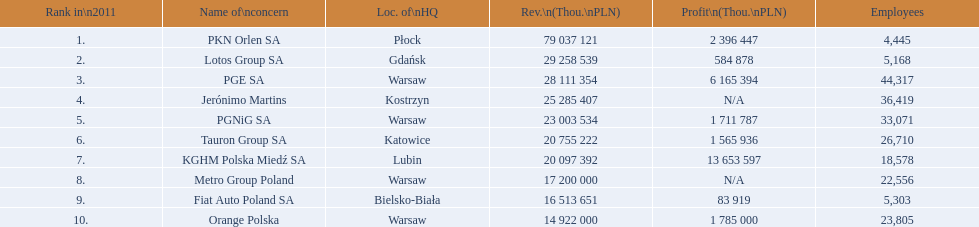What are the names of the major companies of poland? PKN Orlen SA, Lotos Group SA, PGE SA, Jerónimo Martins, PGNiG SA, Tauron Group SA, KGHM Polska Miedź SA, Metro Group Poland, Fiat Auto Poland SA, Orange Polska. What are the revenues of those companies in thou. pln? PKN Orlen SA, 79 037 121, Lotos Group SA, 29 258 539, PGE SA, 28 111 354, Jerónimo Martins, 25 285 407, PGNiG SA, 23 003 534, Tauron Group SA, 20 755 222, KGHM Polska Miedź SA, 20 097 392, Metro Group Poland, 17 200 000, Fiat Auto Poland SA, 16 513 651, Orange Polska, 14 922 000. Which of these revenues is greater than 75 000 000 thou. pln? 79 037 121. Which company has a revenue equal to 79 037 121 thou pln? PKN Orlen SA. 